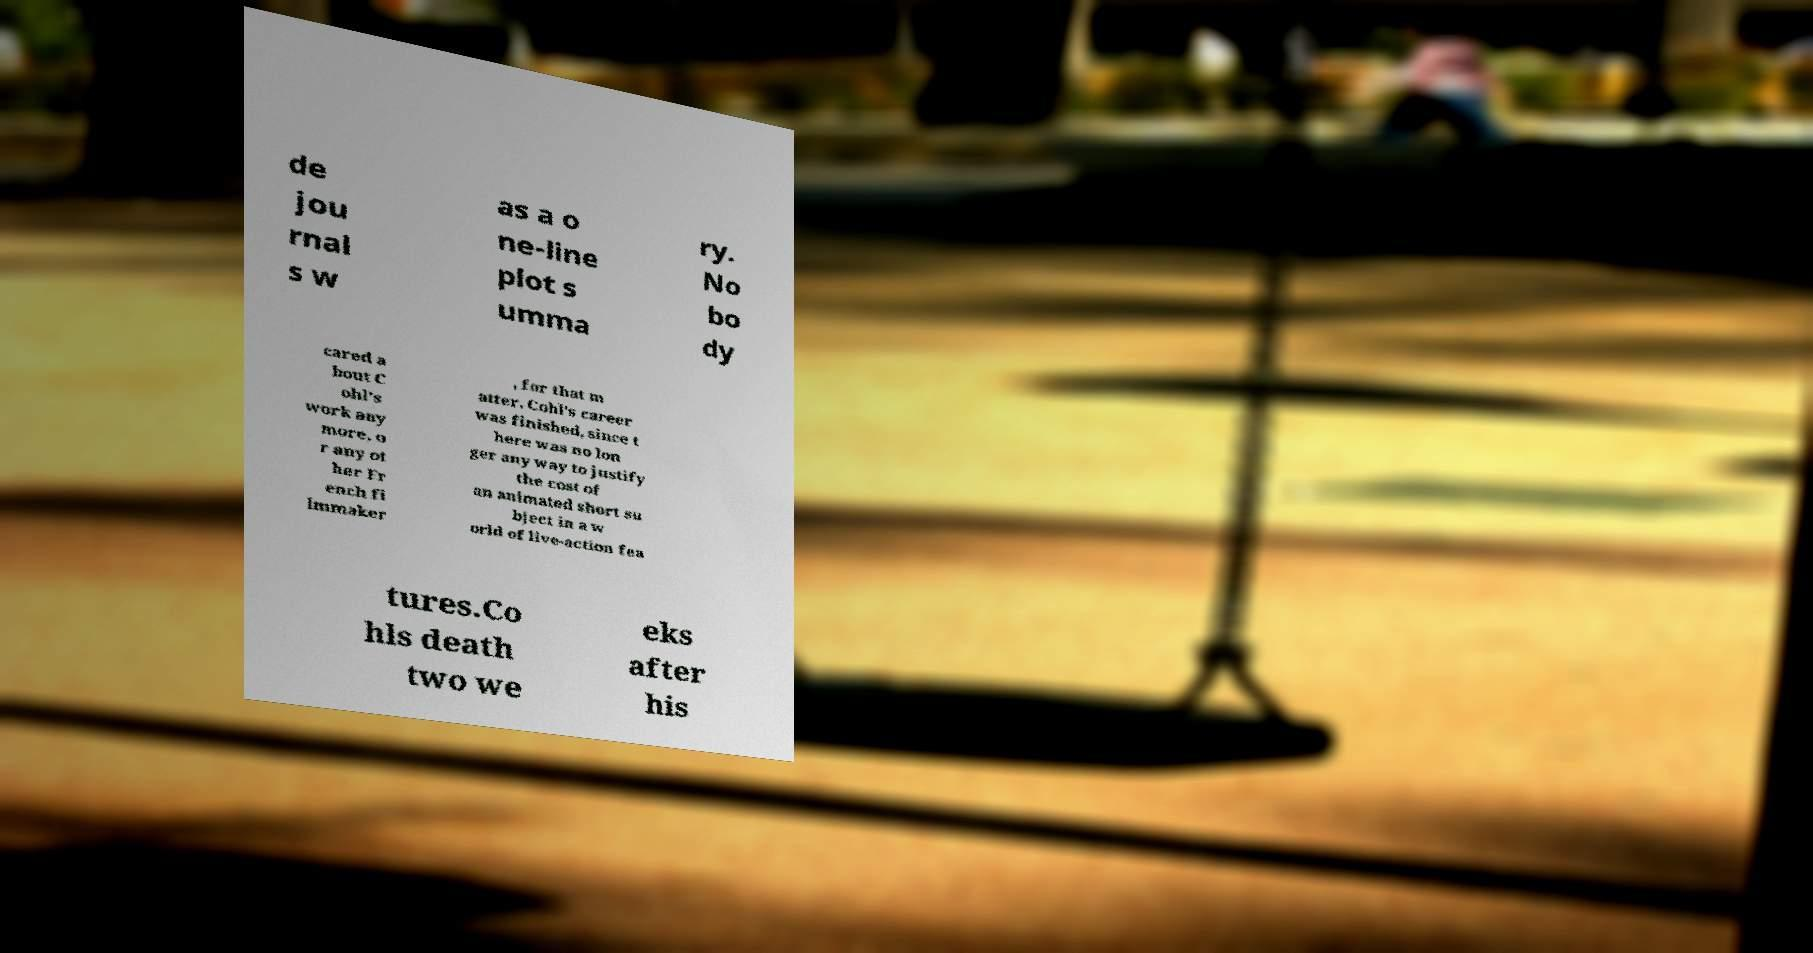I need the written content from this picture converted into text. Can you do that? de jou rnal s w as a o ne-line plot s umma ry. No bo dy cared a bout C ohl's work any more, o r any ot her Fr ench fi lmmaker , for that m atter. Cohl's career was finished, since t here was no lon ger any way to justify the cost of an animated short su bject in a w orld of live-action fea tures.Co hls death two we eks after his 